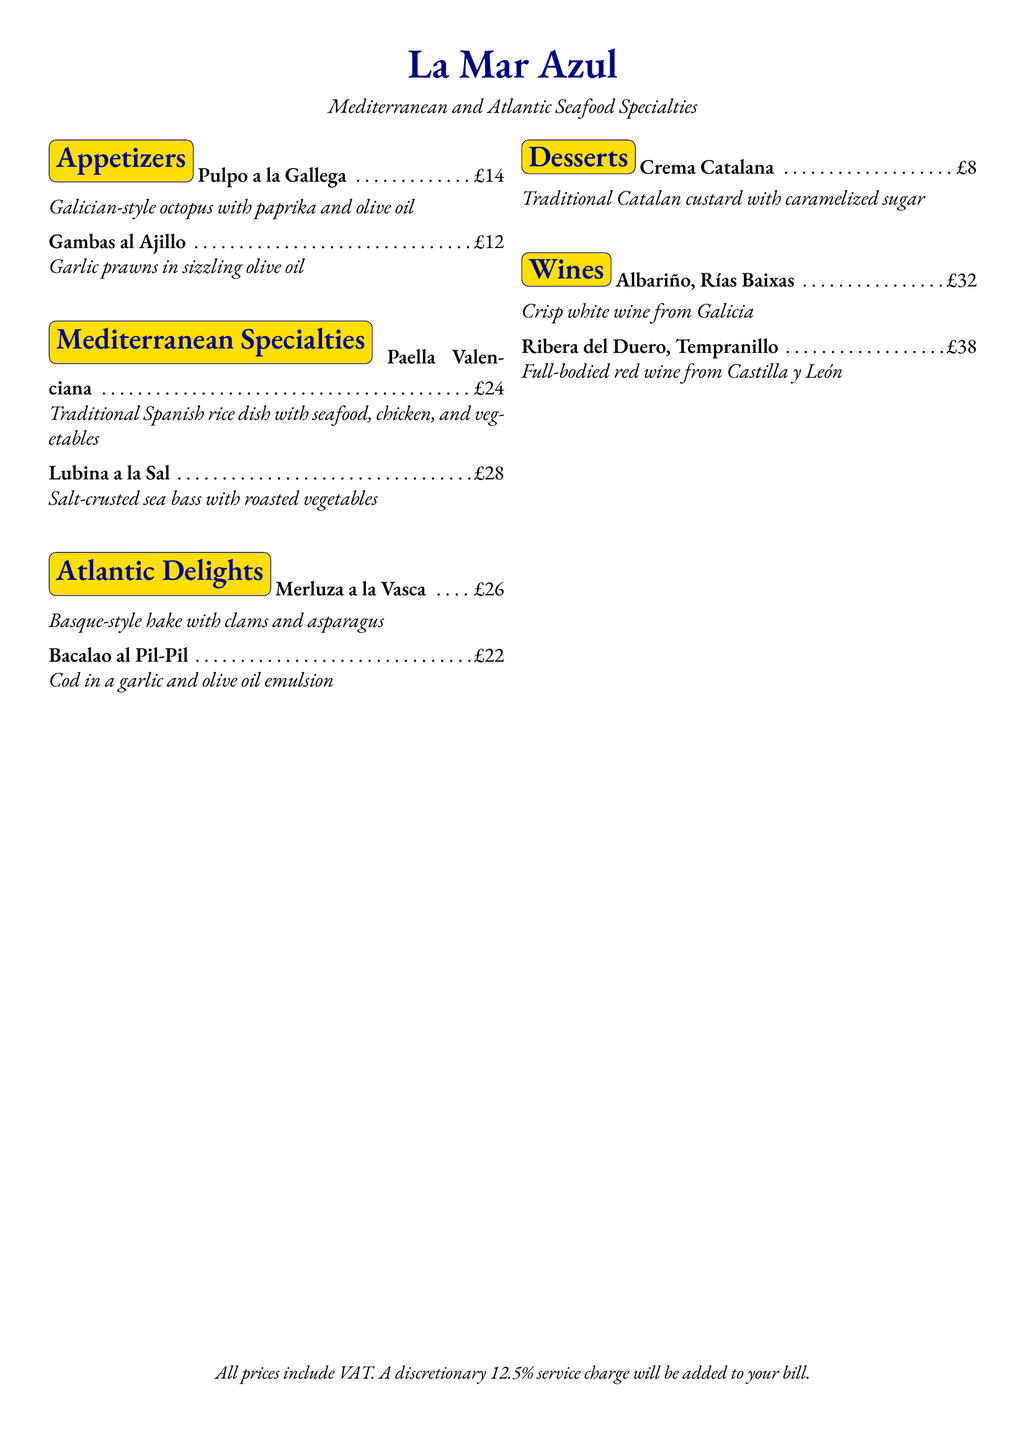What is the name of the restaurant? The restaurant name is prominently displayed at the center of the menu.
Answer: La Mar Azul What is the price of Pulpo a la Gallega? The price of this appetizer is indicated next to the menu item.
Answer: £14 What type of wine is Ribera del Duero? The wine type is specified in the menu alongside the name.
Answer: Tempranillo How much does Desserts cost? The cost of the dessert is stated clearly under the Desserts section.
Answer: £8 Which dish contains clams? This is found in the Atlantic Delights section, under one of the specific items served.
Answer: Merluza a la Vasca What is included in the total price? The menu specifies what is accounted for in prices.
Answer: VAT What percentage is the discretionary service charge? This percentage is mentioned at the bottom of the menu.
Answer: 12.5% Which region's wine is Albariño from? The region is noted next to the wine on the menu.
Answer: Galicia What is the main ingredient in Bacalao al Pil-Pil? The main ingredient is described in the dish's brief description.
Answer: Cod 